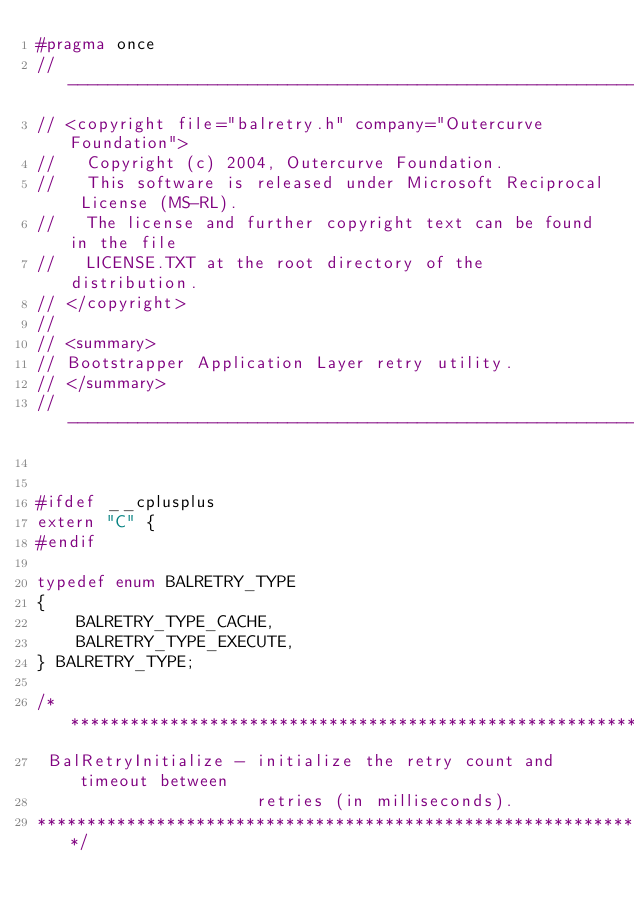<code> <loc_0><loc_0><loc_500><loc_500><_C_>#pragma once
//-------------------------------------------------------------------------------------------------
// <copyright file="balretry.h" company="Outercurve Foundation">
//   Copyright (c) 2004, Outercurve Foundation.
//   This software is released under Microsoft Reciprocal License (MS-RL).
//   The license and further copyright text can be found in the file
//   LICENSE.TXT at the root directory of the distribution.
// </copyright>
// 
// <summary>
// Bootstrapper Application Layer retry utility.
// </summary>
//-------------------------------------------------------------------------------------------------


#ifdef __cplusplus
extern "C" {
#endif

typedef enum BALRETRY_TYPE
{
    BALRETRY_TYPE_CACHE,
    BALRETRY_TYPE_EXECUTE,
} BALRETRY_TYPE;

/*******************************************************************
 BalRetryInitialize - initialize the retry count and timeout between
                      retries (in milliseconds).
********************************************************************/</code> 